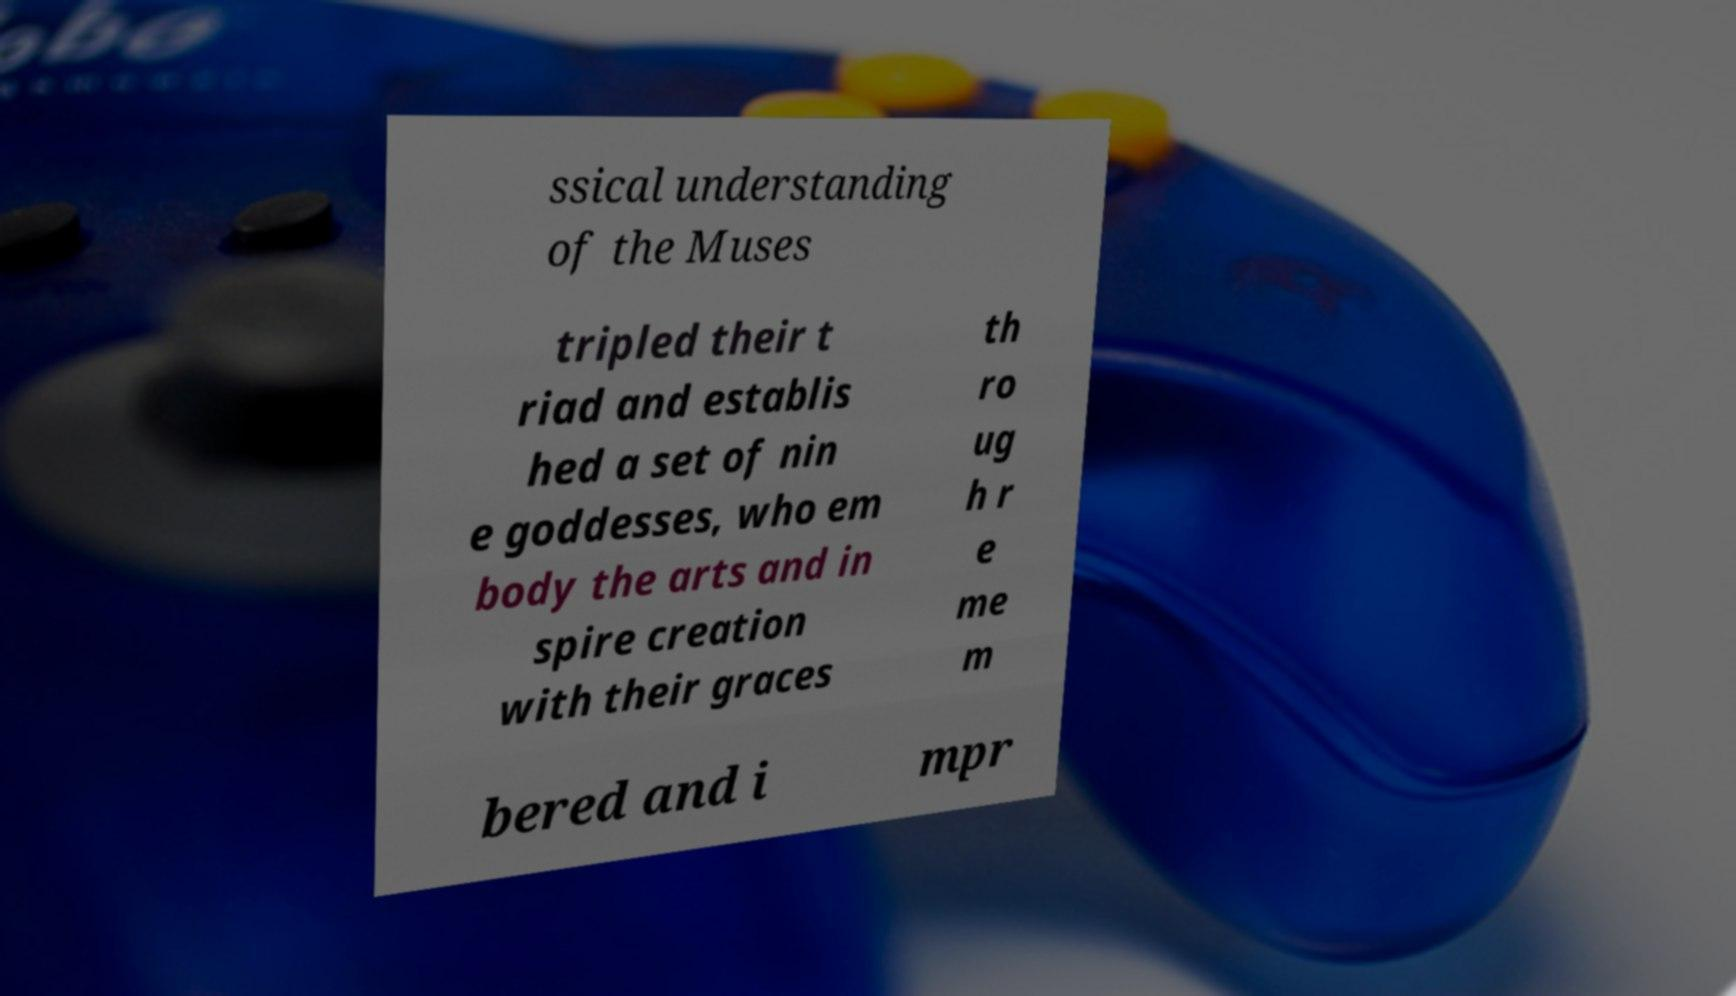Please identify and transcribe the text found in this image. ssical understanding of the Muses tripled their t riad and establis hed a set of nin e goddesses, who em body the arts and in spire creation with their graces th ro ug h r e me m bered and i mpr 